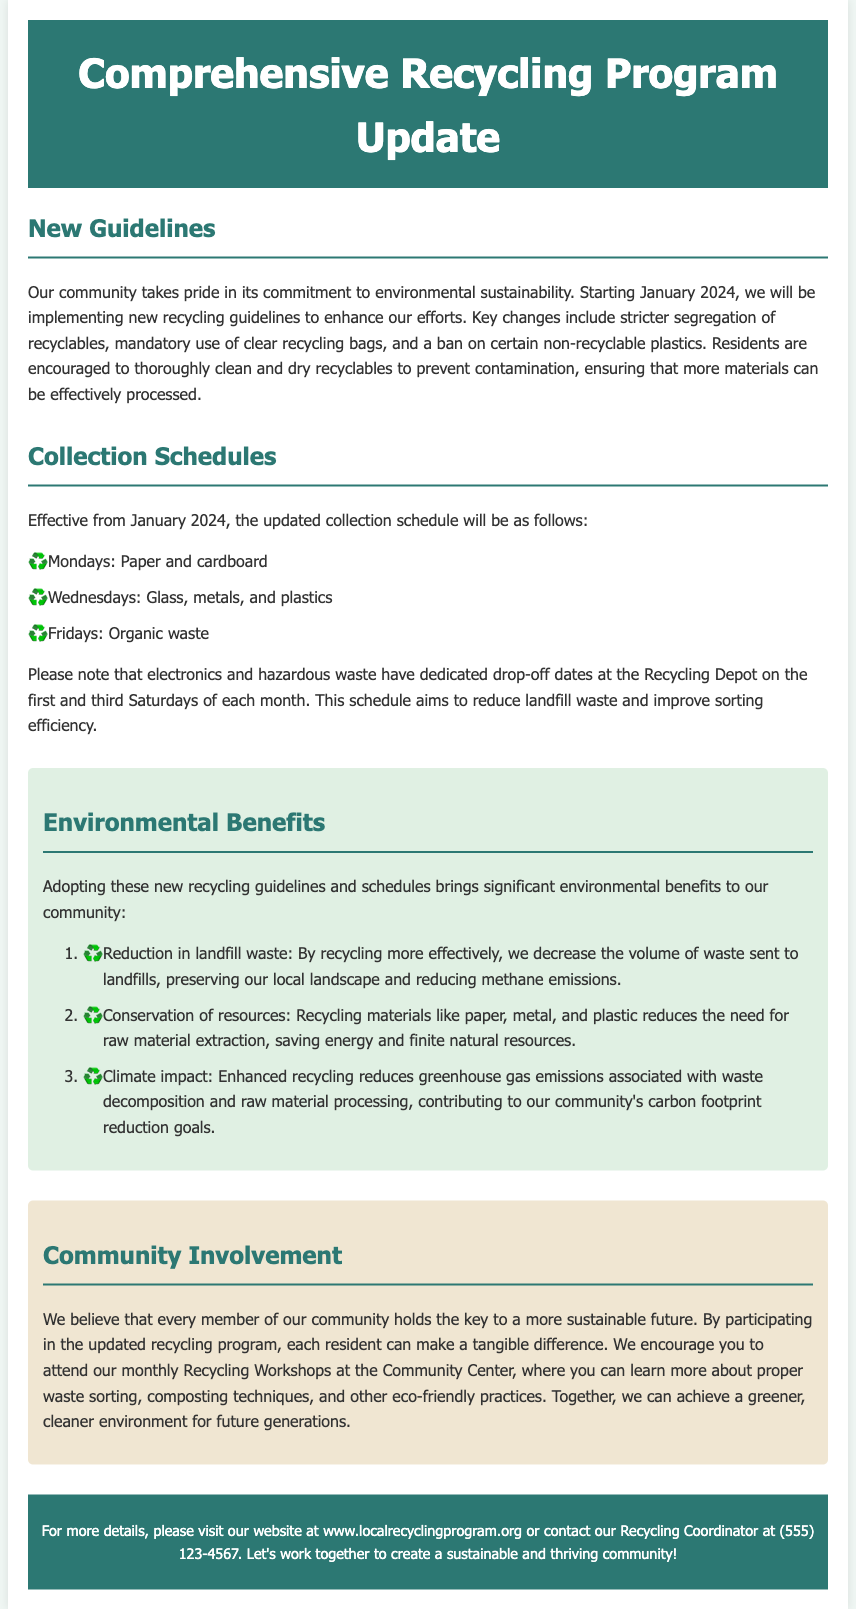What are the new recycling guidelines starting in January 2024? The new recycling guidelines include stricter segregation of recyclables, mandatory use of clear recycling bags, and a ban on certain non-recyclable plastics.
Answer: Stricter segregation, clear bags, ban on non-recyclable plastics What day is designated for paper and cardboard collection? The document states that paper and cardboard will be collected on Mondays.
Answer: Mondays When will the updated collection schedule begin? The updated collection schedule will begin in January 2024.
Answer: January 2024 How many environmental benefits are listed in the document? The document lists three environmental benefits related to the updated recycling program.
Answer: Three What key natural resource is conserved by recycling? The document mentions that recycling materials like paper, metal, and plastic conserves natural resources.
Answer: Natural resources What types of waste have dedicated drop-off dates? The document specifies that electronics and hazardous waste have dedicated drop-off dates.
Answer: Electronics and hazardous waste What community activity is encouraged to learn about recycling? The document encourages residents to attend monthly Recycling Workshops at the Community Center.
Answer: Recycling Workshops What is the contact number for the Recycling Coordinator? The document provides the contact number for the Recycling Coordinator as (555) 123-4567.
Answer: (555) 123-4567 What does the community aim to achieve through the recycling program? The document states that the community aims to achieve a greener, cleaner environment for future generations.
Answer: Greener, cleaner environment 